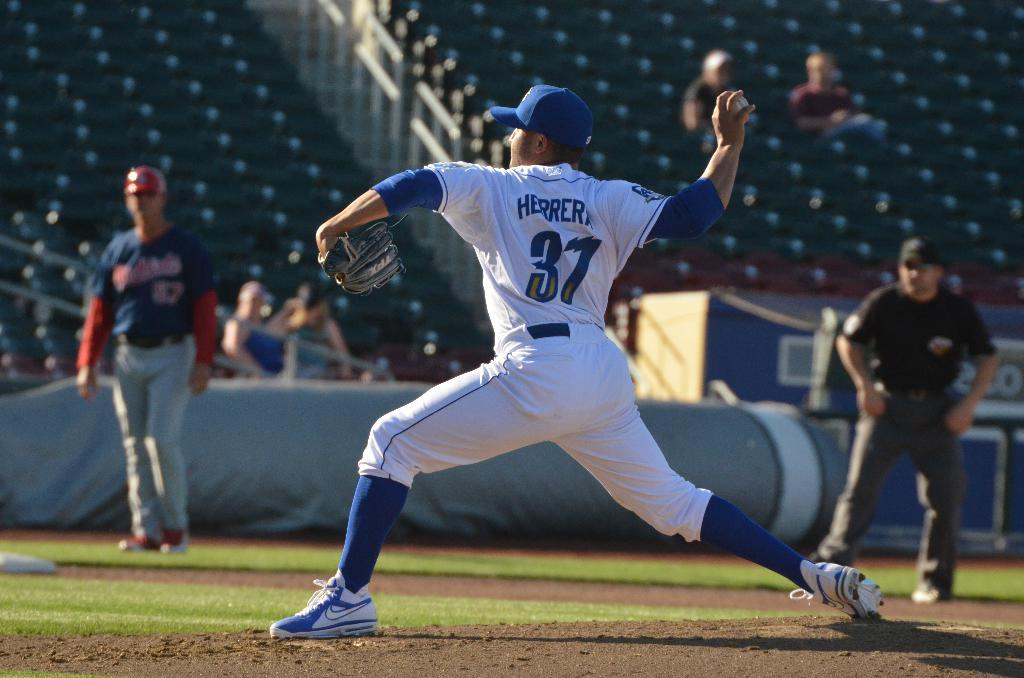Provide a one-sentence caption for the provided image. Herrera throwing a pitch for the baseball game with some fans looking on. 